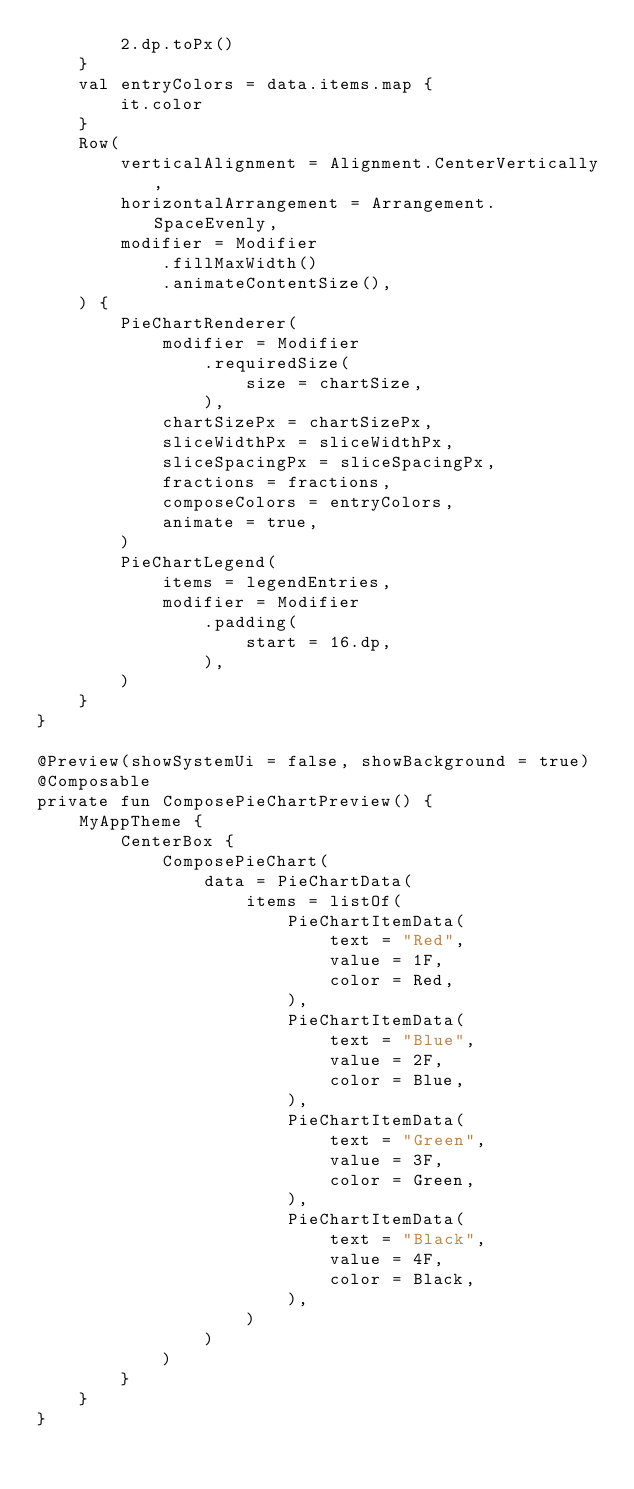<code> <loc_0><loc_0><loc_500><loc_500><_Kotlin_>        2.dp.toPx()
    }
    val entryColors = data.items.map {
        it.color
    }
    Row(
        verticalAlignment = Alignment.CenterVertically,
        horizontalArrangement = Arrangement.SpaceEvenly,
        modifier = Modifier
            .fillMaxWidth()
            .animateContentSize(),
    ) {
        PieChartRenderer(
            modifier = Modifier
                .requiredSize(
                    size = chartSize,
                ),
            chartSizePx = chartSizePx,
            sliceWidthPx = sliceWidthPx,
            sliceSpacingPx = sliceSpacingPx,
            fractions = fractions,
            composeColors = entryColors,
            animate = true,
        )
        PieChartLegend(
            items = legendEntries,
            modifier = Modifier
                .padding(
                    start = 16.dp,
                ),
        )
    }
}

@Preview(showSystemUi = false, showBackground = true)
@Composable
private fun ComposePieChartPreview() {
    MyAppTheme {
        CenterBox {
            ComposePieChart(
                data = PieChartData(
                    items = listOf(
                        PieChartItemData(
                            text = "Red",
                            value = 1F,
                            color = Red,
                        ),
                        PieChartItemData(
                            text = "Blue",
                            value = 2F,
                            color = Blue,
                        ),
                        PieChartItemData(
                            text = "Green",
                            value = 3F,
                            color = Green,
                        ),
                        PieChartItemData(
                            text = "Black",
                            value = 4F,
                            color = Black,
                        ),
                    )
                )
            )
        }
    }
}
</code> 